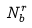Convert formula to latex. <formula><loc_0><loc_0><loc_500><loc_500>N _ { b } ^ { r }</formula> 